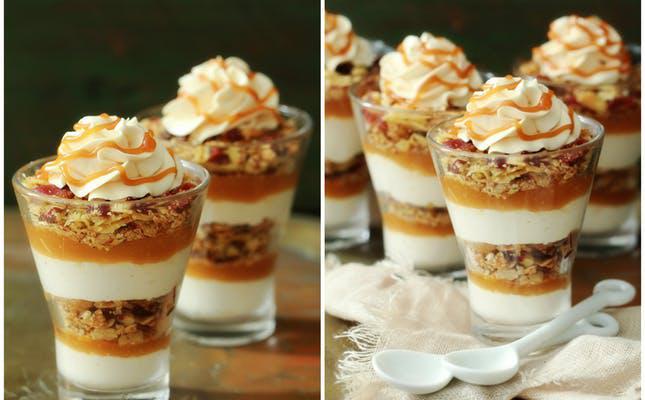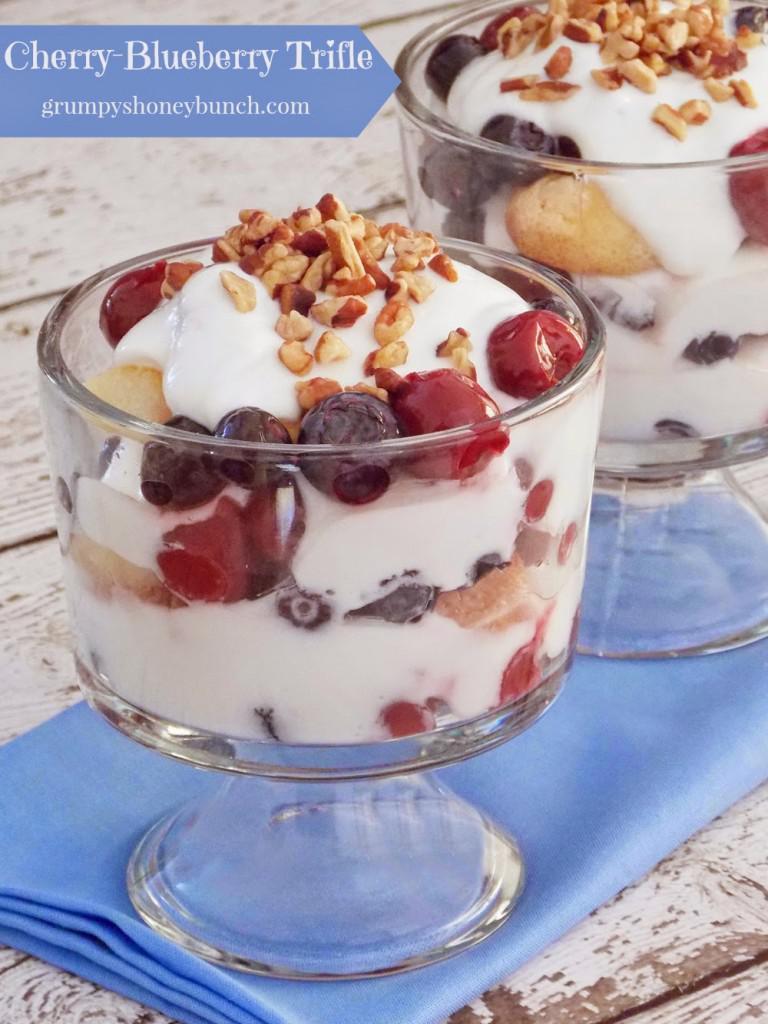The first image is the image on the left, the second image is the image on the right. For the images displayed, is the sentence "The dessert on the left does not contain any berries." factually correct? Answer yes or no. Yes. 